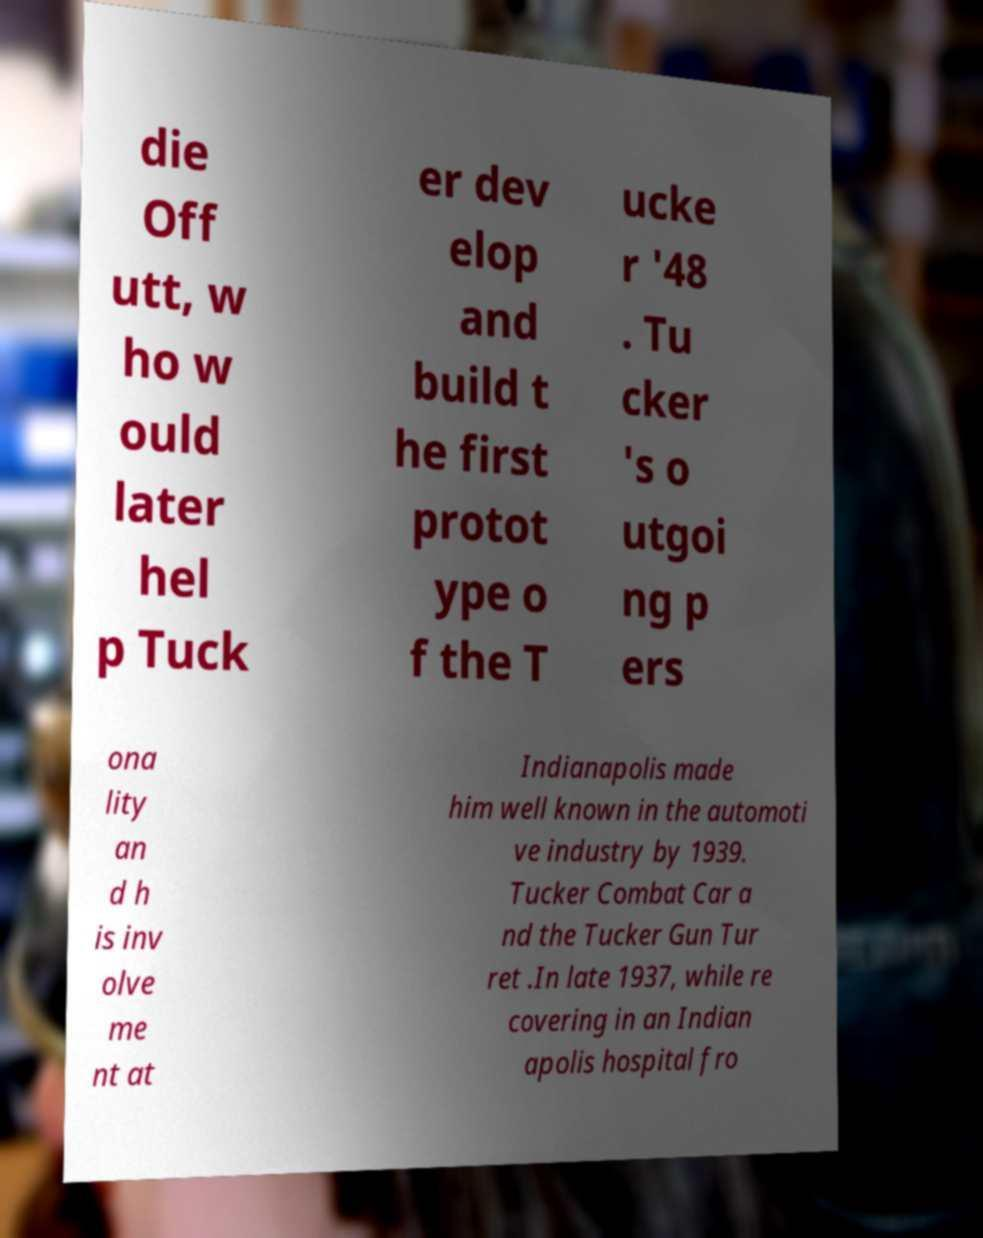Can you read and provide the text displayed in the image?This photo seems to have some interesting text. Can you extract and type it out for me? die Off utt, w ho w ould later hel p Tuck er dev elop and build t he first protot ype o f the T ucke r '48 . Tu cker 's o utgoi ng p ers ona lity an d h is inv olve me nt at Indianapolis made him well known in the automoti ve industry by 1939. Tucker Combat Car a nd the Tucker Gun Tur ret .In late 1937, while re covering in an Indian apolis hospital fro 